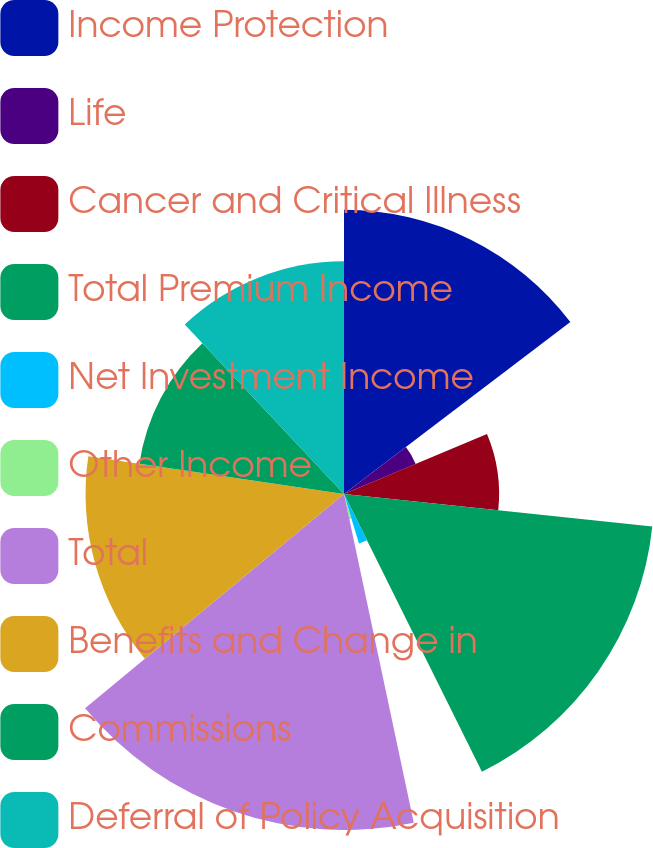Convert chart to OTSL. <chart><loc_0><loc_0><loc_500><loc_500><pie_chart><fcel>Income Protection<fcel>Life<fcel>Cancer and Critical Illness<fcel>Total Premium Income<fcel>Net Investment Income<fcel>Other Income<fcel>Total<fcel>Benefits and Change in<fcel>Commissions<fcel>Deferral of Policy Acquisition<nl><fcel>14.66%<fcel>4.01%<fcel>8.0%<fcel>15.99%<fcel>2.67%<fcel>1.34%<fcel>17.33%<fcel>13.33%<fcel>10.67%<fcel>12.0%<nl></chart> 